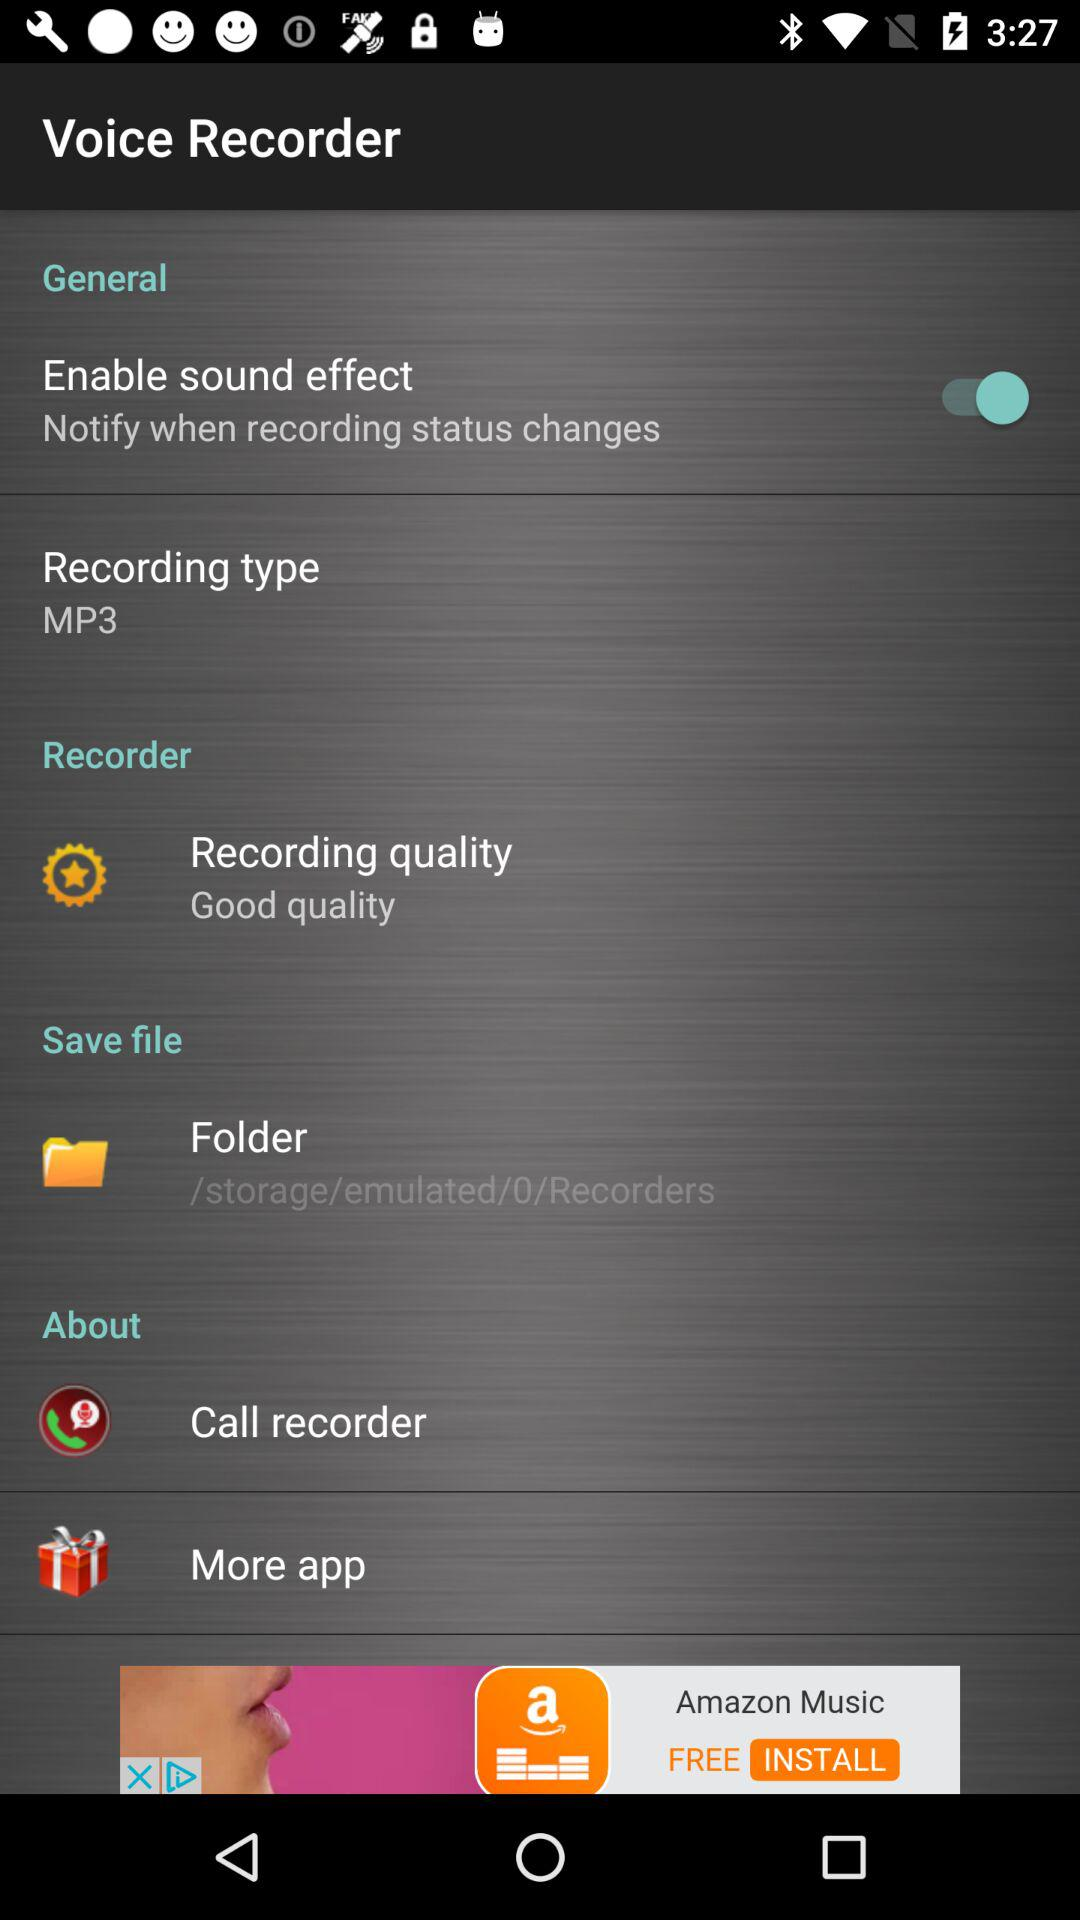What is the recording quality? The recording quality is good. 